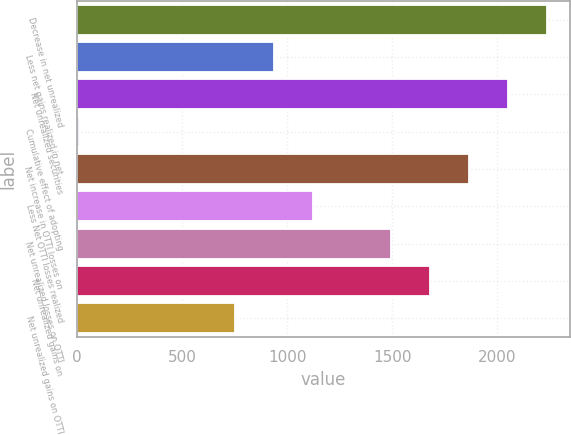Convert chart. <chart><loc_0><loc_0><loc_500><loc_500><bar_chart><fcel>Decrease in net unrealized<fcel>Less net gains realized in net<fcel>Net unrealized securities<fcel>Cumulative effect of adopting<fcel>Net increase in OTTI losses on<fcel>Less Net OTTI losses realized<fcel>Net unrealized losses on OTTI<fcel>Net unrealized gains on<fcel>Net unrealized gains on OTTI<nl><fcel>2234.2<fcel>935<fcel>2048.6<fcel>7<fcel>1863<fcel>1120.6<fcel>1491.8<fcel>1677.4<fcel>749.4<nl></chart> 